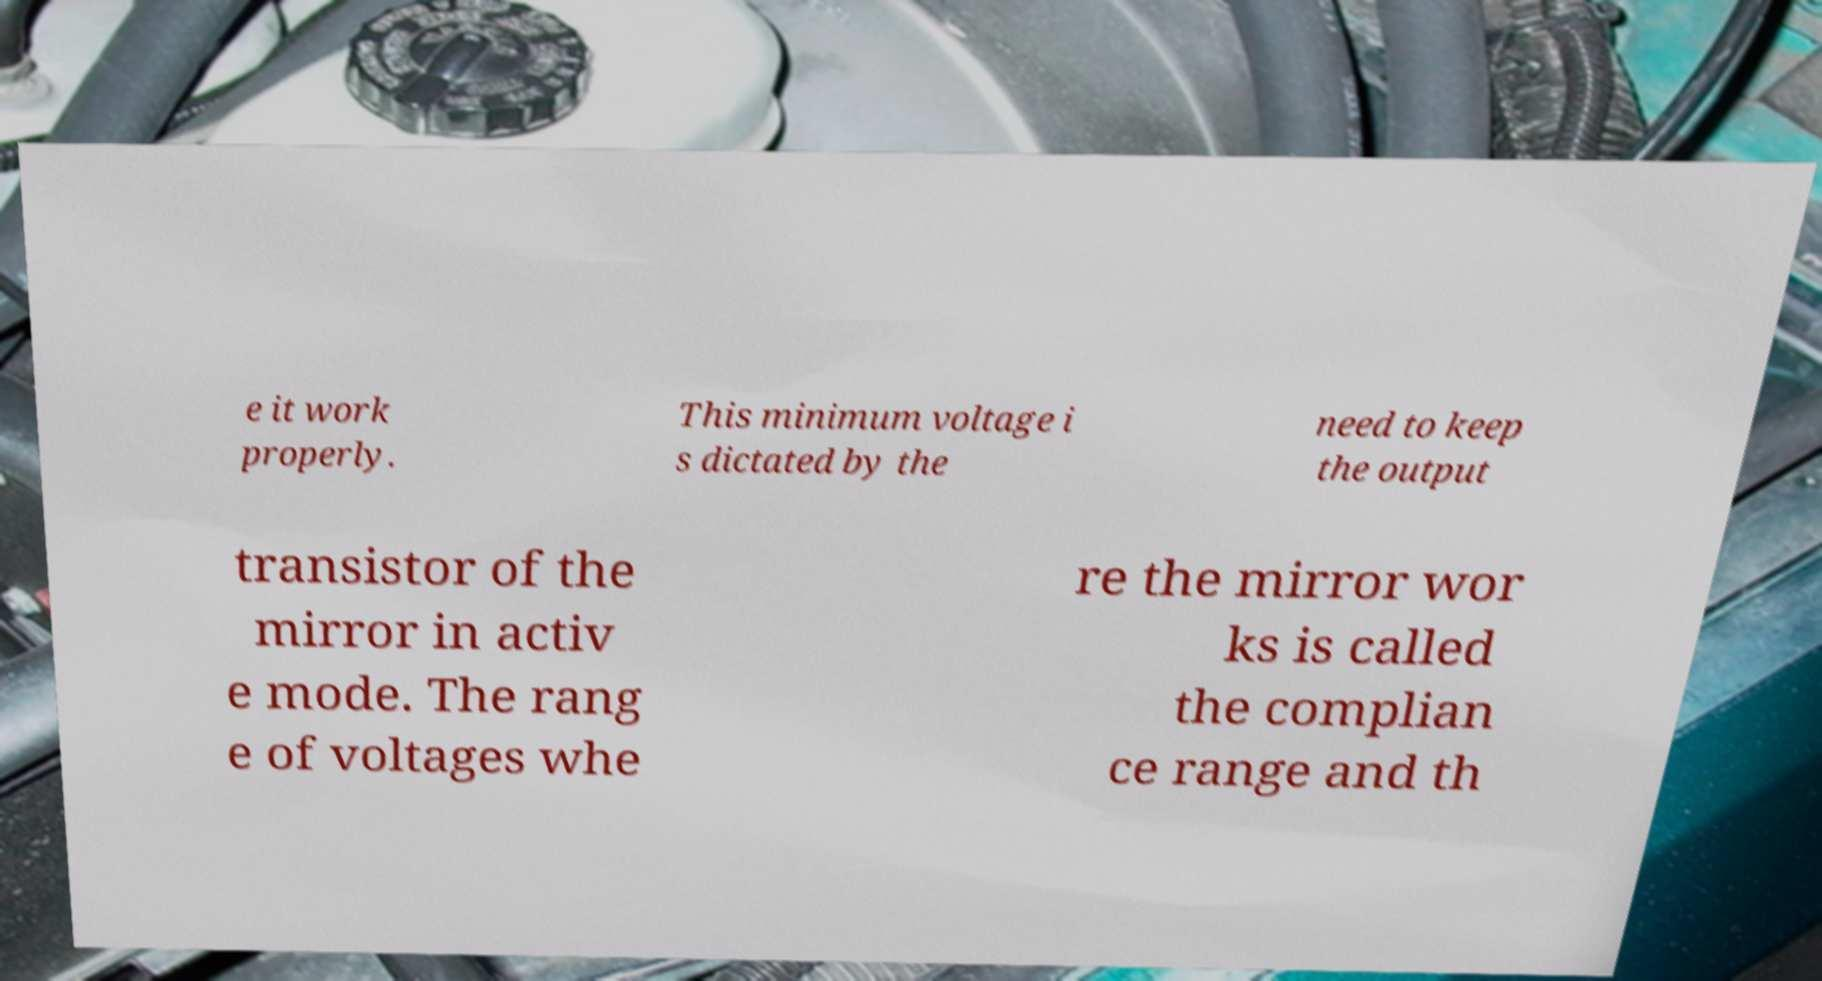Please identify and transcribe the text found in this image. e it work properly. This minimum voltage i s dictated by the need to keep the output transistor of the mirror in activ e mode. The rang e of voltages whe re the mirror wor ks is called the complian ce range and th 